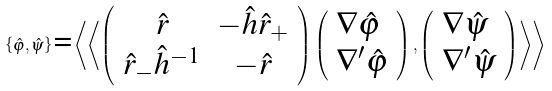Convert formula to latex. <formula><loc_0><loc_0><loc_500><loc_500>\left \{ \hat { \varphi } , \hat { \psi } \right \} \text {=} \left \langle \left \langle \left ( \begin{array} { c c } \hat { r } & - \hat { h } \hat { r } _ { + } \\ \hat { r } _ { - } \hat { h } ^ { - 1 } & - \hat { r } \end{array} \right ) \left ( \begin{array} { l } \nabla \hat { \varphi } \\ \nabla ^ { \prime } \hat { \varphi } \end{array} \right ) , \left ( \begin{array} { l } \nabla \hat { \psi } \\ \nabla ^ { \prime } \hat { \psi } \end{array} \right ) \right \rangle \right \rangle</formula> 